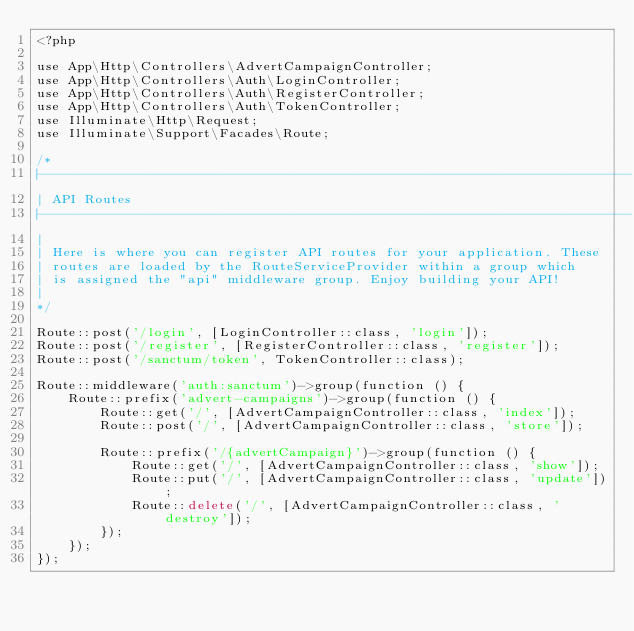<code> <loc_0><loc_0><loc_500><loc_500><_PHP_><?php

use App\Http\Controllers\AdvertCampaignController;
use App\Http\Controllers\Auth\LoginController;
use App\Http\Controllers\Auth\RegisterController;
use App\Http\Controllers\Auth\TokenController;
use Illuminate\Http\Request;
use Illuminate\Support\Facades\Route;

/*
|--------------------------------------------------------------------------
| API Routes
|--------------------------------------------------------------------------
|
| Here is where you can register API routes for your application. These
| routes are loaded by the RouteServiceProvider within a group which
| is assigned the "api" middleware group. Enjoy building your API!
|
*/

Route::post('/login', [LoginController::class, 'login']);
Route::post('/register', [RegisterController::class, 'register']);
Route::post('/sanctum/token', TokenController::class);

Route::middleware('auth:sanctum')->group(function () {
    Route::prefix('advert-campaigns')->group(function () {
        Route::get('/', [AdvertCampaignController::class, 'index']);
        Route::post('/', [AdvertCampaignController::class, 'store']);

        Route::prefix('/{advertCampaign}')->group(function () {
            Route::get('/', [AdvertCampaignController::class, 'show']);
            Route::put('/', [AdvertCampaignController::class, 'update']);
            Route::delete('/', [AdvertCampaignController::class, 'destroy']);
        });
    });
});
</code> 